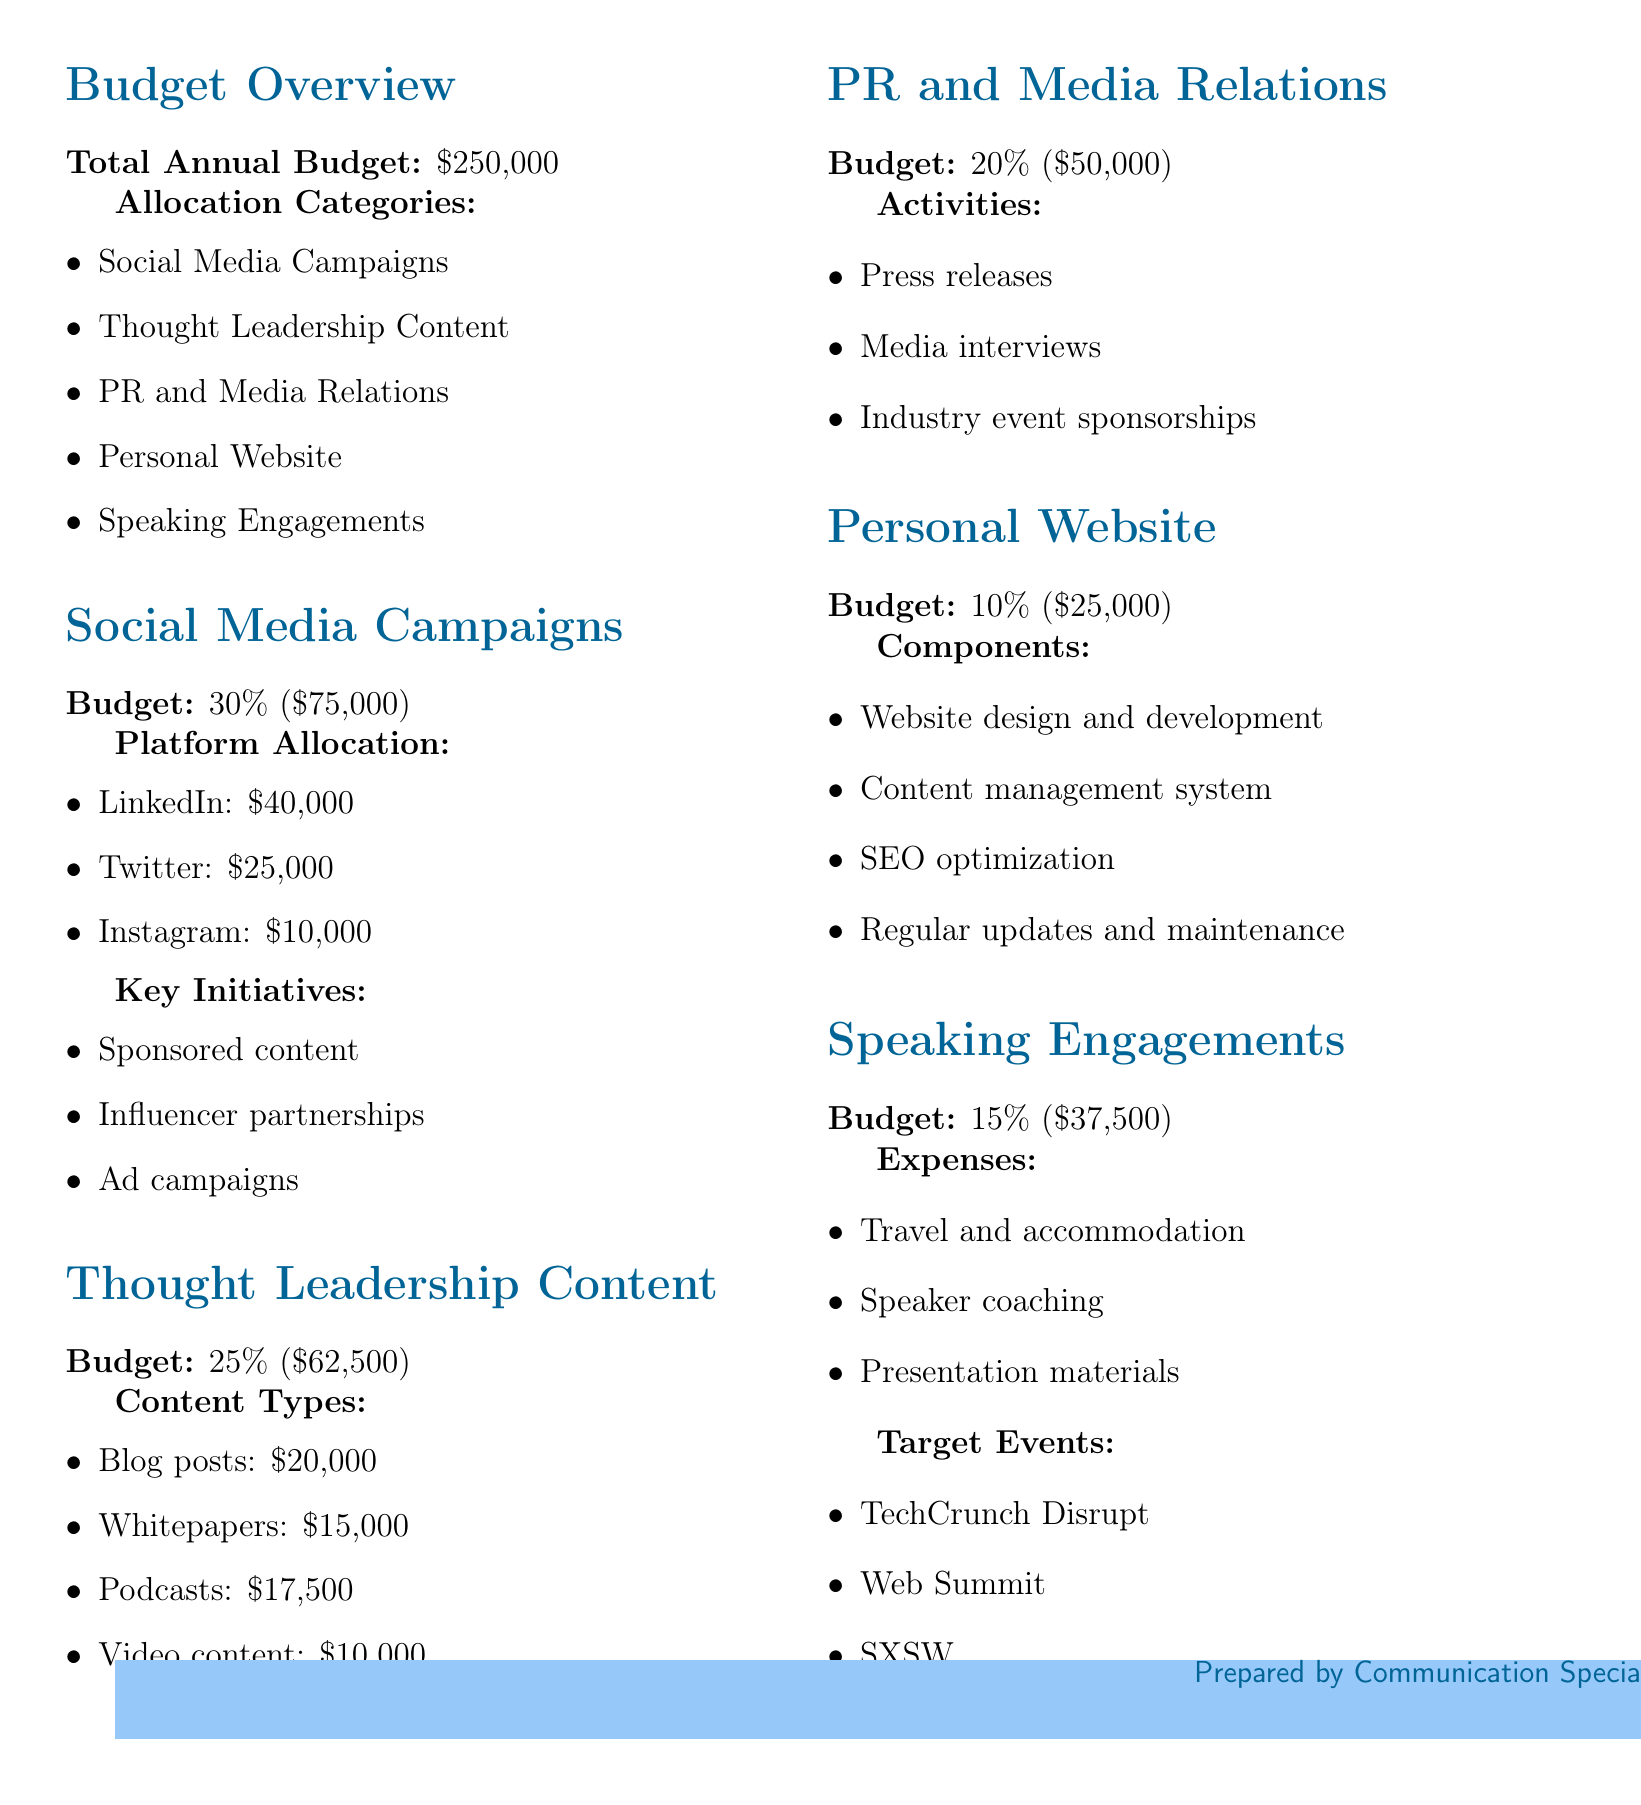What is the total annual budget? The total annual budget is directly stated in the document as $250,000.
Answer: $250,000 What percentage of the budget is allocated to social media campaigns? The document specifies that social media campaigns receive 30% of the total budget.
Answer: 30% How much is allocated for LinkedIn specifically? The document lists the allocation for LinkedIn as $40,000.
Answer: $40,000 What are the key initiatives for social media campaigns? The document states that the key initiatives include sponsored content, influencer partnerships, and ad campaigns.
Answer: Sponsored content, influencer partnerships, ad campaigns How much is budgeted for speaking engagements? The total amount dedicated to speaking engagements is mentioned as $37,500.
Answer: $37,500 Which content type is allocated the most budget for thought leadership content? The document notes that blog posts receive the largest allocation at $20,000.
Answer: Blog posts What activities fall under PR and media relations? The activities under PR and media relations are press releases, media interviews, and industry event sponsorships as listed in the document.
Answer: Press releases, media interviews, industry event sponsorships What is the budget percentage for personal website development? The allocation percentage for the personal website is stated as 10%.
Answer: 10% Which target events are associated with speaking engagements? The document lists TechCrunch Disrupt, Web Summit, and SXSW as target events for speaking engagements.
Answer: TechCrunch Disrupt, Web Summit, SXSW 